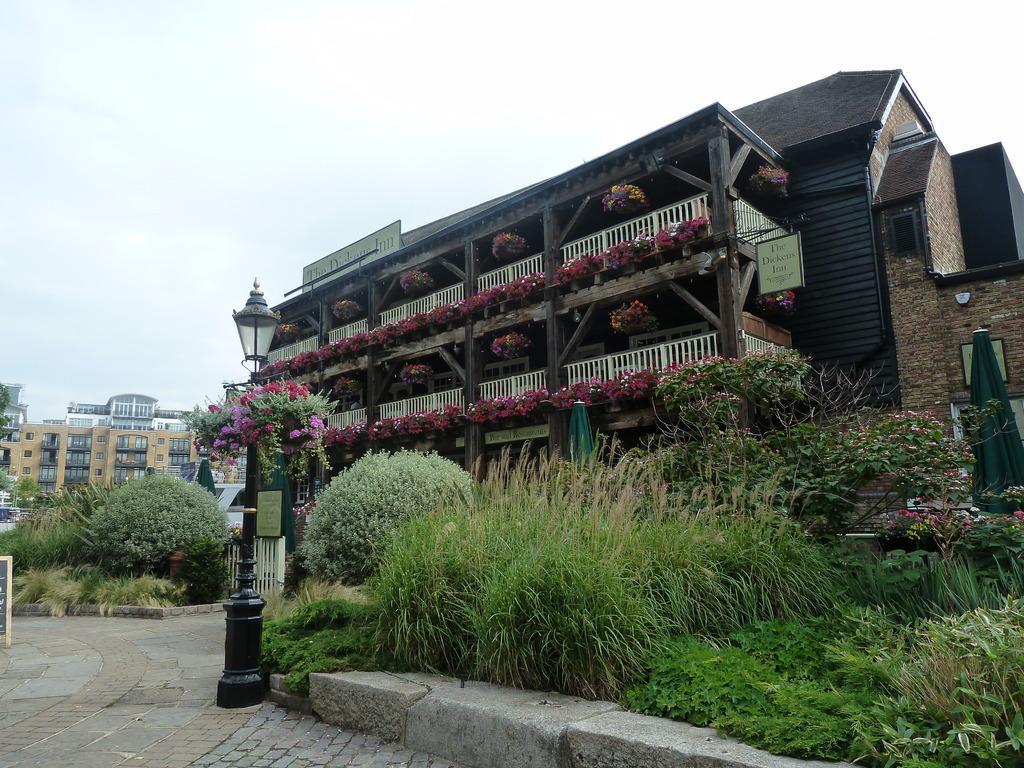Can you describe this image briefly? In this picture there is wooden house with white color balcony and some flower. Behind there are many building and in the front bottom side we can see some plants. 